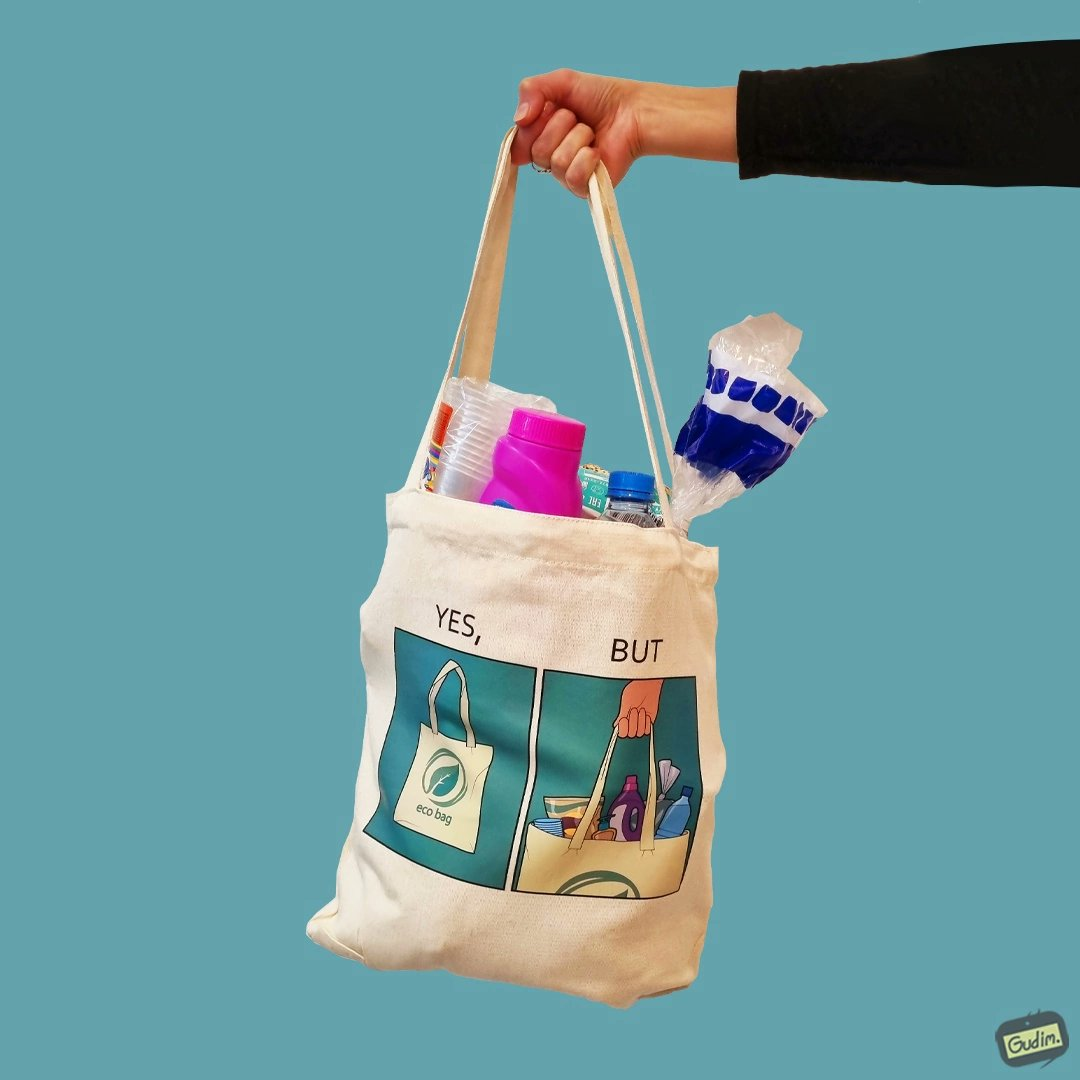What do you see in each half of this image? In the left part of the image: A picture of a bag with eco bag written on it. In the right part of the image: The image of the material that is kept in the bag. 